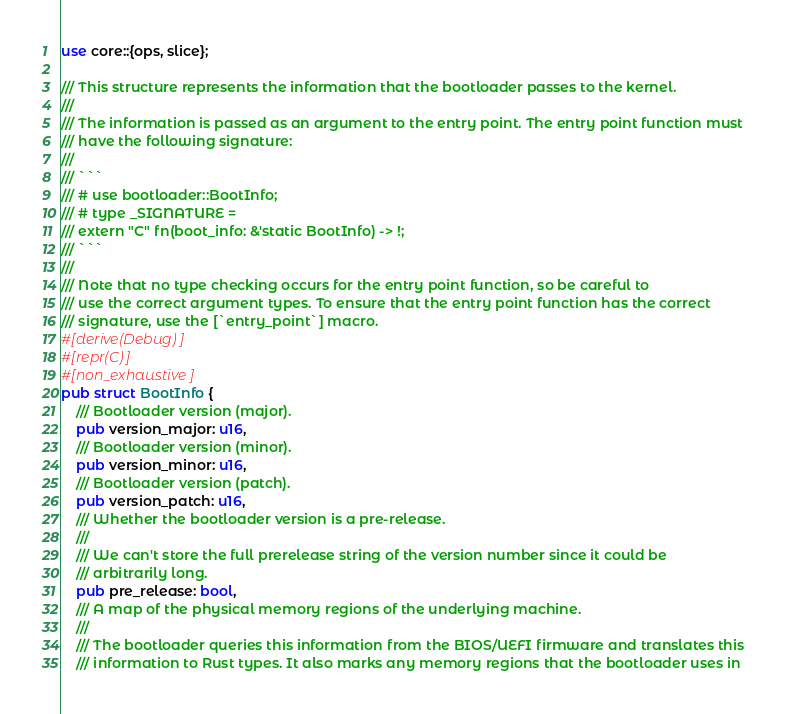<code> <loc_0><loc_0><loc_500><loc_500><_Rust_>use core::{ops, slice};

/// This structure represents the information that the bootloader passes to the kernel.
///
/// The information is passed as an argument to the entry point. The entry point function must
/// have the following signature:
///
/// ```
/// # use bootloader::BootInfo;
/// # type _SIGNATURE =
/// extern "C" fn(boot_info: &'static BootInfo) -> !;
/// ```
///
/// Note that no type checking occurs for the entry point function, so be careful to
/// use the correct argument types. To ensure that the entry point function has the correct
/// signature, use the [`entry_point`] macro.
#[derive(Debug)]
#[repr(C)]
#[non_exhaustive]
pub struct BootInfo {
    /// Bootloader version (major).
    pub version_major: u16,
    /// Bootloader version (minor).
    pub version_minor: u16,
    /// Bootloader version (patch).
    pub version_patch: u16,
    /// Whether the bootloader version is a pre-release.
    ///
    /// We can't store the full prerelease string of the version number since it could be
    /// arbitrarily long.
    pub pre_release: bool,
    /// A map of the physical memory regions of the underlying machine.
    ///
    /// The bootloader queries this information from the BIOS/UEFI firmware and translates this
    /// information to Rust types. It also marks any memory regions that the bootloader uses in</code> 